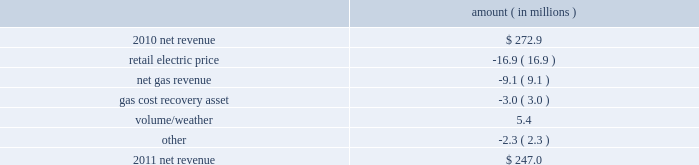Entergy new orleans , inc .
Management 2019s financial discussion and analysis plan to spin off the utility 2019s transmission business see the 201cplan to spin off the utility 2019s transmission business 201d section of entergy corporation and subsidiaries management 2019s financial discussion and analysis for a discussion of this matter , including the planned retirement of debt and preferred securities .
Results of operations net income 2011 compared to 2010 net income increased $ 4.9 million primarily due to lower other operation and maintenance expenses , lower taxes other than income taxes , a lower effective income tax rate , and lower interest expense , partially offset by lower net revenue .
2010 compared to 2009 net income remained relatively unchanged , increasing $ 0.6 million , primarily due to higher net revenue and lower interest expense , almost entirely offset by higher other operation and maintenance expenses , higher taxes other than income taxes , lower other income , and higher depreciation and amortization expenses .
Net revenue 2011 compared to 2010 net revenue consists of operating revenues net of : 1 ) fuel , fuel-related expenses , and gas purchased for resale , 2 ) purchased power expenses , and 3 ) other regulatory charges ( credits ) .
Following is an analysis of the change in net revenue comparing 2011 to 2010 .
Amount ( in millions ) .
The retail electric price variance is primarily due to formula rate plan decreases effective october 2010 and october 2011 .
See note 2 to the financial statements for a discussion of the formula rate plan filing .
The net gas revenue variance is primarily due to milder weather in 2011 compared to 2010 .
The gas cost recovery asset variance is primarily due to the recognition in 2010 of a $ 3 million gas operations regulatory asset associated with the settlement of entergy new orleans 2019s electric and gas formula rate plan case and the amortization of that asset .
See note 2 to the financial statements for additional discussion of the formula rate plan settlement. .
In 2010 what was the ratio of the net gas revenue to the gas cost recovery asset ( 3.0 )? 
Computations: (9.1 / 3.0)
Answer: 3.03333. Entergy new orleans , inc .
Management 2019s financial discussion and analysis plan to spin off the utility 2019s transmission business see the 201cplan to spin off the utility 2019s transmission business 201d section of entergy corporation and subsidiaries management 2019s financial discussion and analysis for a discussion of this matter , including the planned retirement of debt and preferred securities .
Results of operations net income 2011 compared to 2010 net income increased $ 4.9 million primarily due to lower other operation and maintenance expenses , lower taxes other than income taxes , a lower effective income tax rate , and lower interest expense , partially offset by lower net revenue .
2010 compared to 2009 net income remained relatively unchanged , increasing $ 0.6 million , primarily due to higher net revenue and lower interest expense , almost entirely offset by higher other operation and maintenance expenses , higher taxes other than income taxes , lower other income , and higher depreciation and amortization expenses .
Net revenue 2011 compared to 2010 net revenue consists of operating revenues net of : 1 ) fuel , fuel-related expenses , and gas purchased for resale , 2 ) purchased power expenses , and 3 ) other regulatory charges ( credits ) .
Following is an analysis of the change in net revenue comparing 2011 to 2010 .
Amount ( in millions ) .
The retail electric price variance is primarily due to formula rate plan decreases effective october 2010 and october 2011 .
See note 2 to the financial statements for a discussion of the formula rate plan filing .
The net gas revenue variance is primarily due to milder weather in 2011 compared to 2010 .
The gas cost recovery asset variance is primarily due to the recognition in 2010 of a $ 3 million gas operations regulatory asset associated with the settlement of entergy new orleans 2019s electric and gas formula rate plan case and the amortization of that asset .
See note 2 to the financial statements for additional discussion of the formula rate plan settlement. .
What is the growth rate in net revenue from 2010 to 2011? 
Computations: ((247.0 - 272.9) / 272.9)
Answer: -0.09491. 